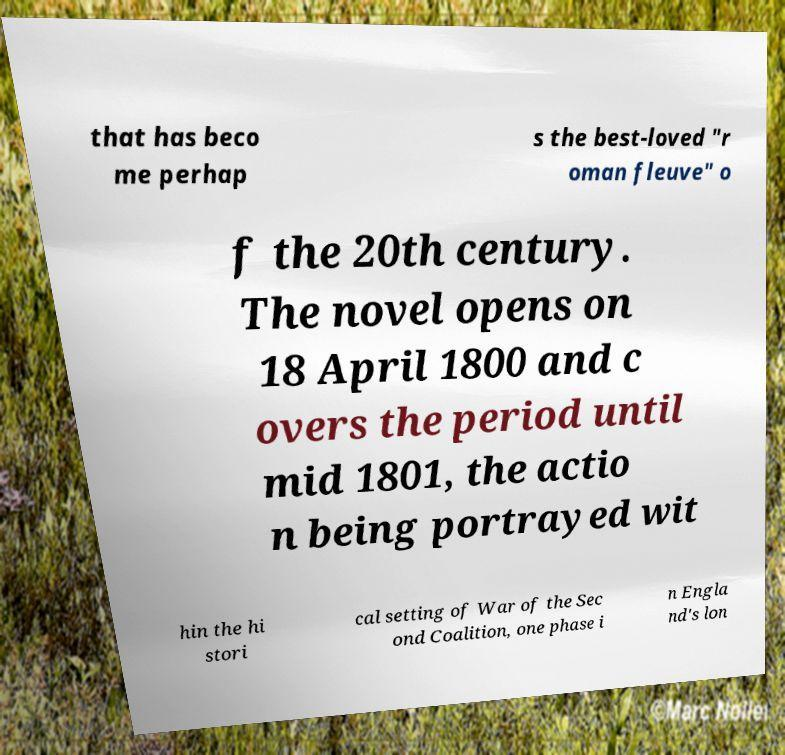There's text embedded in this image that I need extracted. Can you transcribe it verbatim? that has beco me perhap s the best-loved "r oman fleuve" o f the 20th century. The novel opens on 18 April 1800 and c overs the period until mid 1801, the actio n being portrayed wit hin the hi stori cal setting of War of the Sec ond Coalition, one phase i n Engla nd's lon 